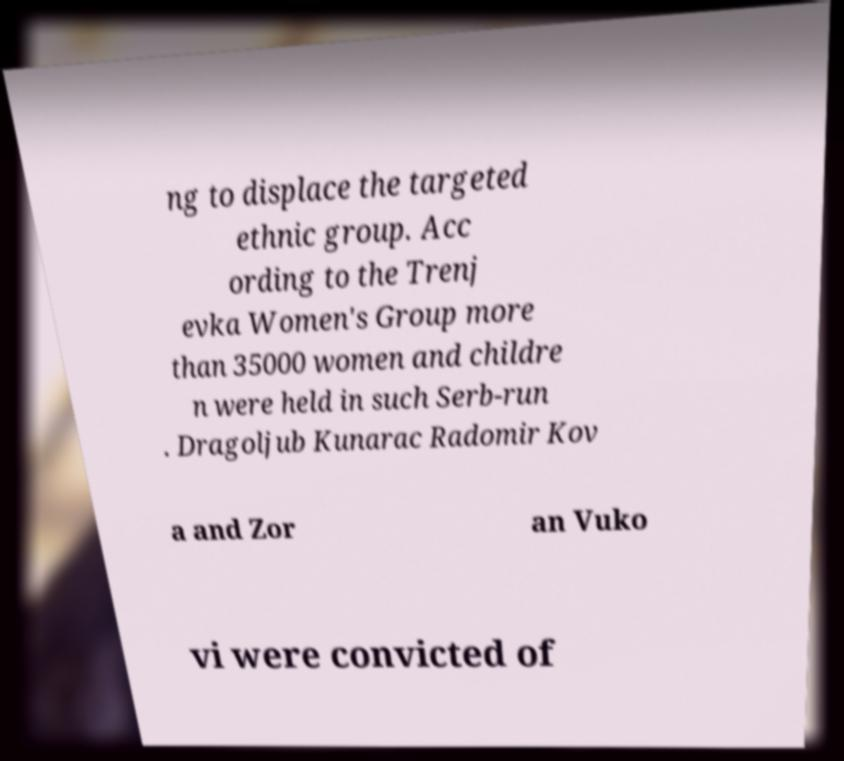I need the written content from this picture converted into text. Can you do that? ng to displace the targeted ethnic group. Acc ording to the Trenj evka Women's Group more than 35000 women and childre n were held in such Serb-run . Dragoljub Kunarac Radomir Kov a and Zor an Vuko vi were convicted of 